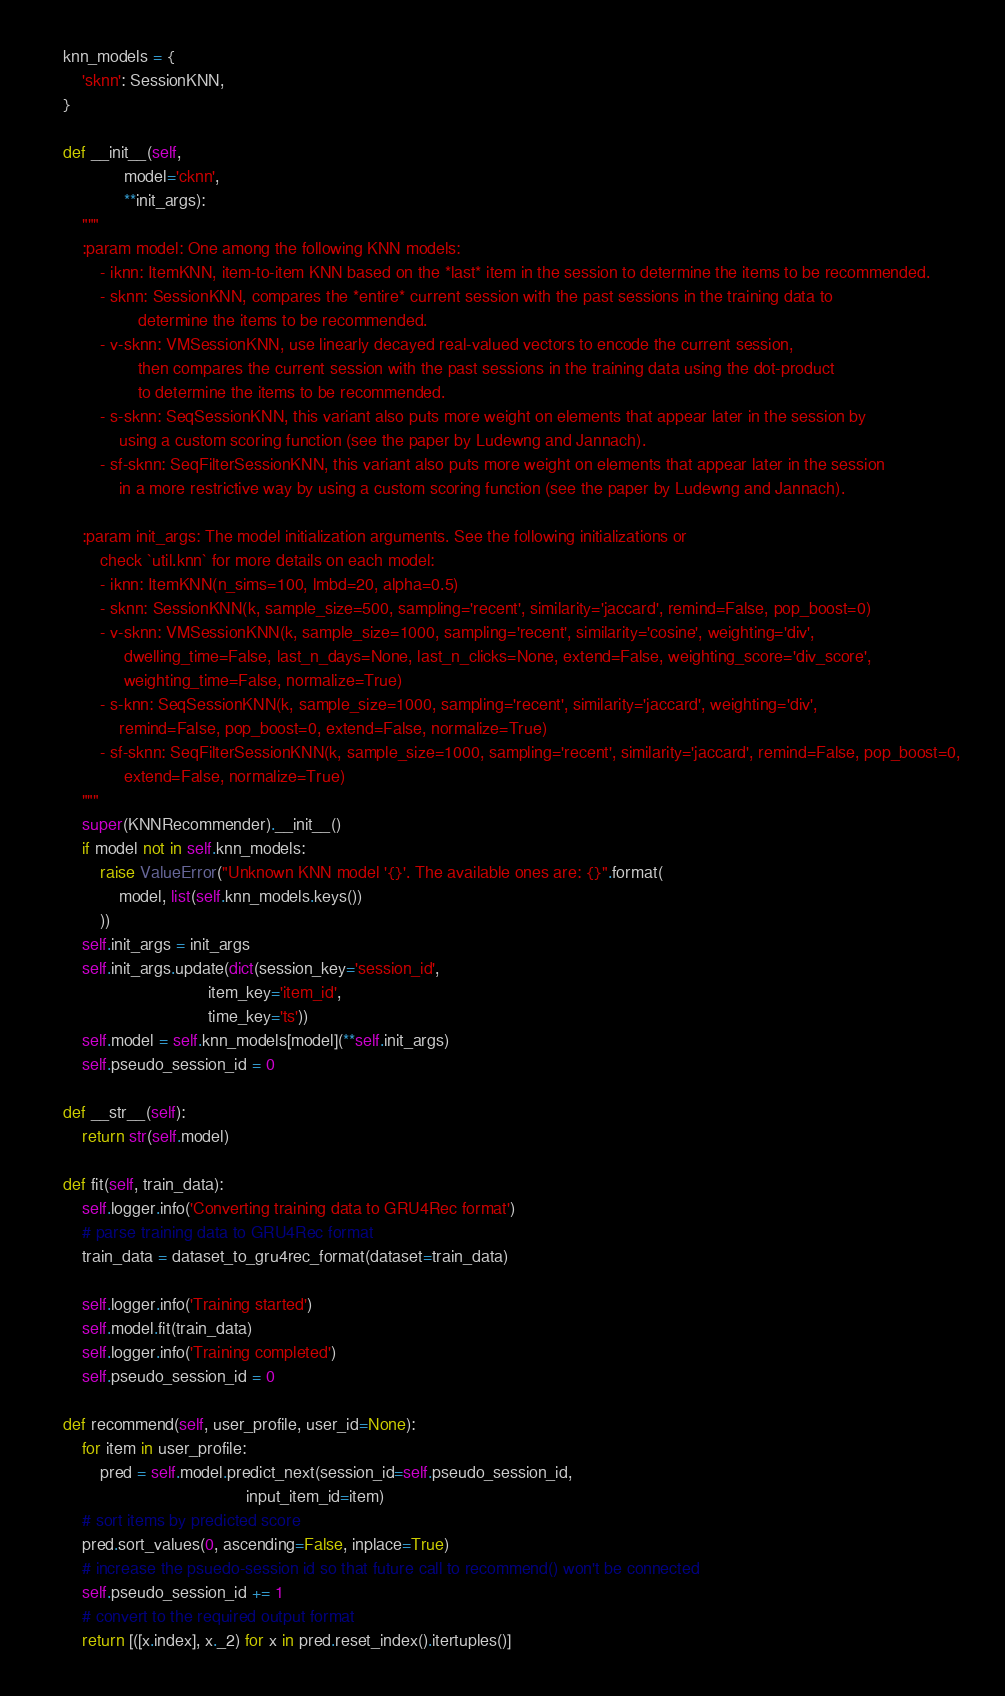Convert code to text. <code><loc_0><loc_0><loc_500><loc_500><_Python_>    knn_models = {
        'sknn': SessionKNN,
    }

    def __init__(self,
                 model='cknn',
                 **init_args):
        """
        :param model: One among the following KNN models:
            - iknn: ItemKNN, item-to-item KNN based on the *last* item in the session to determine the items to be recommended.
            - sknn: SessionKNN, compares the *entire* current session with the past sessions in the training data to
                    determine the items to be recommended.
            - v-sknn: VMSessionKNN, use linearly decayed real-valued vectors to encode the current session,
                    then compares the current session with the past sessions in the training data using the dot-product
                    to determine the items to be recommended.
            - s-sknn: SeqSessionKNN, this variant also puts more weight on elements that appear later in the session by
                using a custom scoring function (see the paper by Ludewng and Jannach).
            - sf-sknn: SeqFilterSessionKNN, this variant also puts more weight on elements that appear later in the session
                in a more restrictive way by using a custom scoring function (see the paper by Ludewng and Jannach).

        :param init_args: The model initialization arguments. See the following initializations or
            check `util.knn` for more details on each model:
            - iknn: ItemKNN(n_sims=100, lmbd=20, alpha=0.5)
            - sknn: SessionKNN(k, sample_size=500, sampling='recent', similarity='jaccard', remind=False, pop_boost=0)
            - v-sknn: VMSessionKNN(k, sample_size=1000, sampling='recent', similarity='cosine', weighting='div',
                 dwelling_time=False, last_n_days=None, last_n_clicks=None, extend=False, weighting_score='div_score',
                 weighting_time=False, normalize=True)
            - s-knn: SeqSessionKNN(k, sample_size=1000, sampling='recent', similarity='jaccard', weighting='div',
                remind=False, pop_boost=0, extend=False, normalize=True)
            - sf-sknn: SeqFilterSessionKNN(k, sample_size=1000, sampling='recent', similarity='jaccard', remind=False, pop_boost=0,
                 extend=False, normalize=True)
        """
        super(KNNRecommender).__init__()
        if model not in self.knn_models:
            raise ValueError("Unknown KNN model '{}'. The available ones are: {}".format(
                model, list(self.knn_models.keys())
            ))
        self.init_args = init_args
        self.init_args.update(dict(session_key='session_id',
                                   item_key='item_id',
                                   time_key='ts'))
        self.model = self.knn_models[model](**self.init_args)
        self.pseudo_session_id = 0

    def __str__(self):
        return str(self.model)

    def fit(self, train_data):
        self.logger.info('Converting training data to GRU4Rec format')
        # parse training data to GRU4Rec format
        train_data = dataset_to_gru4rec_format(dataset=train_data)

        self.logger.info('Training started')
        self.model.fit(train_data)
        self.logger.info('Training completed')
        self.pseudo_session_id = 0

    def recommend(self, user_profile, user_id=None):
        for item in user_profile:
            pred = self.model.predict_next(session_id=self.pseudo_session_id,
                                           input_item_id=item)
        # sort items by predicted score
        pred.sort_values(0, ascending=False, inplace=True)
        # increase the psuedo-session id so that future call to recommend() won't be connected
        self.pseudo_session_id += 1
        # convert to the required output format
        return [([x.index], x._2) for x in pred.reset_index().itertuples()]
</code> 